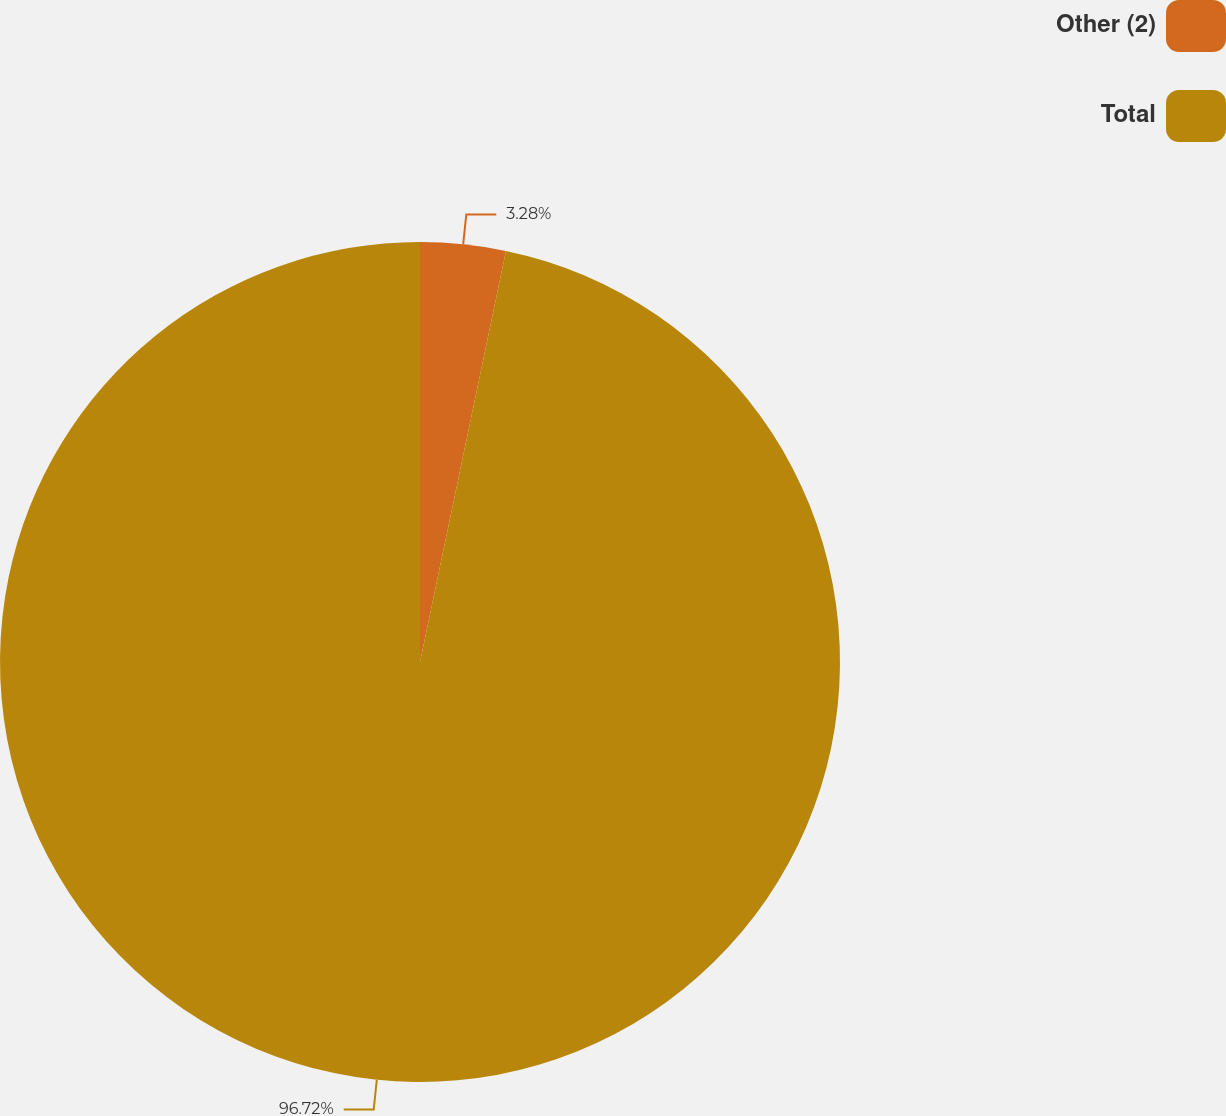Convert chart. <chart><loc_0><loc_0><loc_500><loc_500><pie_chart><fcel>Other (2)<fcel>Total<nl><fcel>3.28%<fcel>96.72%<nl></chart> 